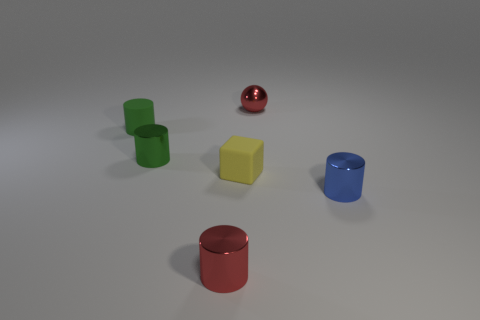What size is the other matte thing that is the same shape as the small blue object?
Ensure brevity in your answer.  Small. Does the small sphere have the same color as the shiny cylinder that is in front of the small blue metallic object?
Offer a terse response. Yes. There is a cylinder that is the same color as the metal ball; what is its size?
Provide a succinct answer. Small. How many small metal objects have the same color as the tiny ball?
Your response must be concise. 1. What is the material of the object that is the same color as the tiny ball?
Give a very brief answer. Metal. Is there a tiny green cylinder that is behind the red metallic thing on the left side of the red shiny thing behind the green rubber object?
Offer a terse response. Yes. What number of metallic objects are red cylinders or blocks?
Offer a terse response. 1. How many other things are there of the same shape as the tiny blue metallic object?
Provide a succinct answer. 3. Are there more tiny green matte things than red metal things?
Your answer should be compact. No. What size is the metallic cylinder that is in front of the small metal thing that is on the right side of the red metallic object behind the tiny yellow rubber thing?
Keep it short and to the point. Small. 